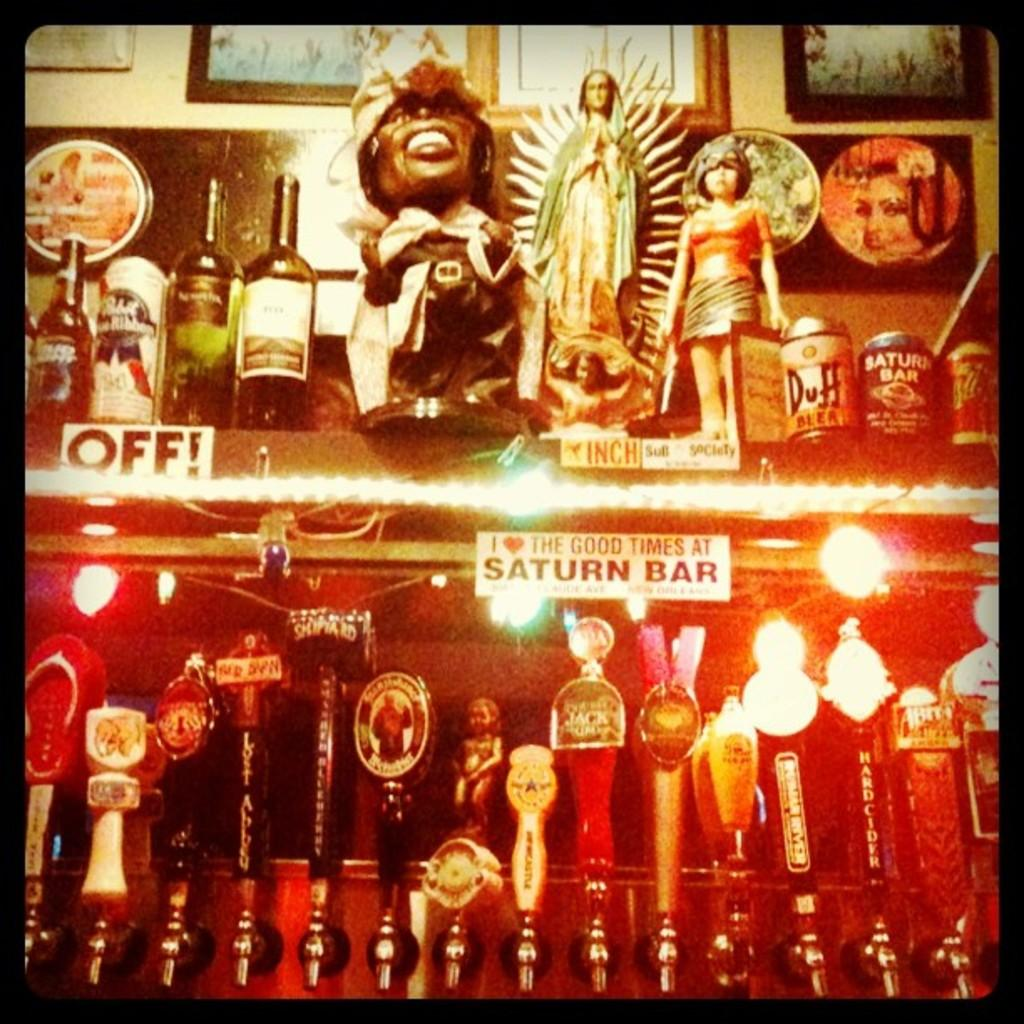Provide a one-sentence caption for the provided image. The Good Times Saturn Bar bumper sticker attached to a shelf with beer drafts under it. 